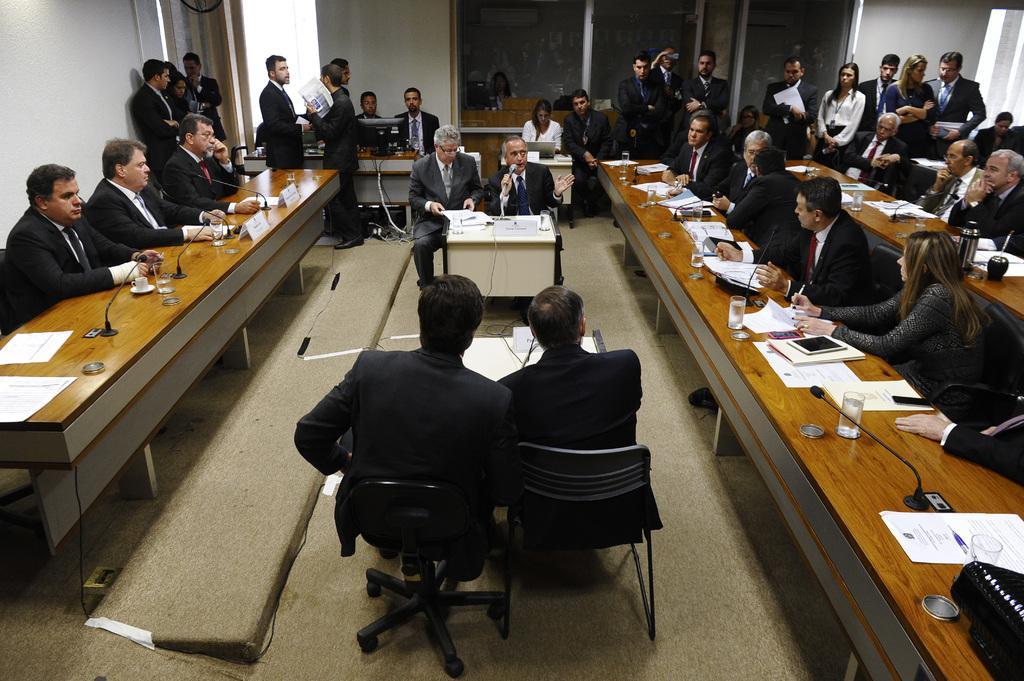Please provide a concise description of this image. In this image there are people sitting on chairs and there are table, on that tables there are mike's, glasses, papers and few are standing around them there are walls. 